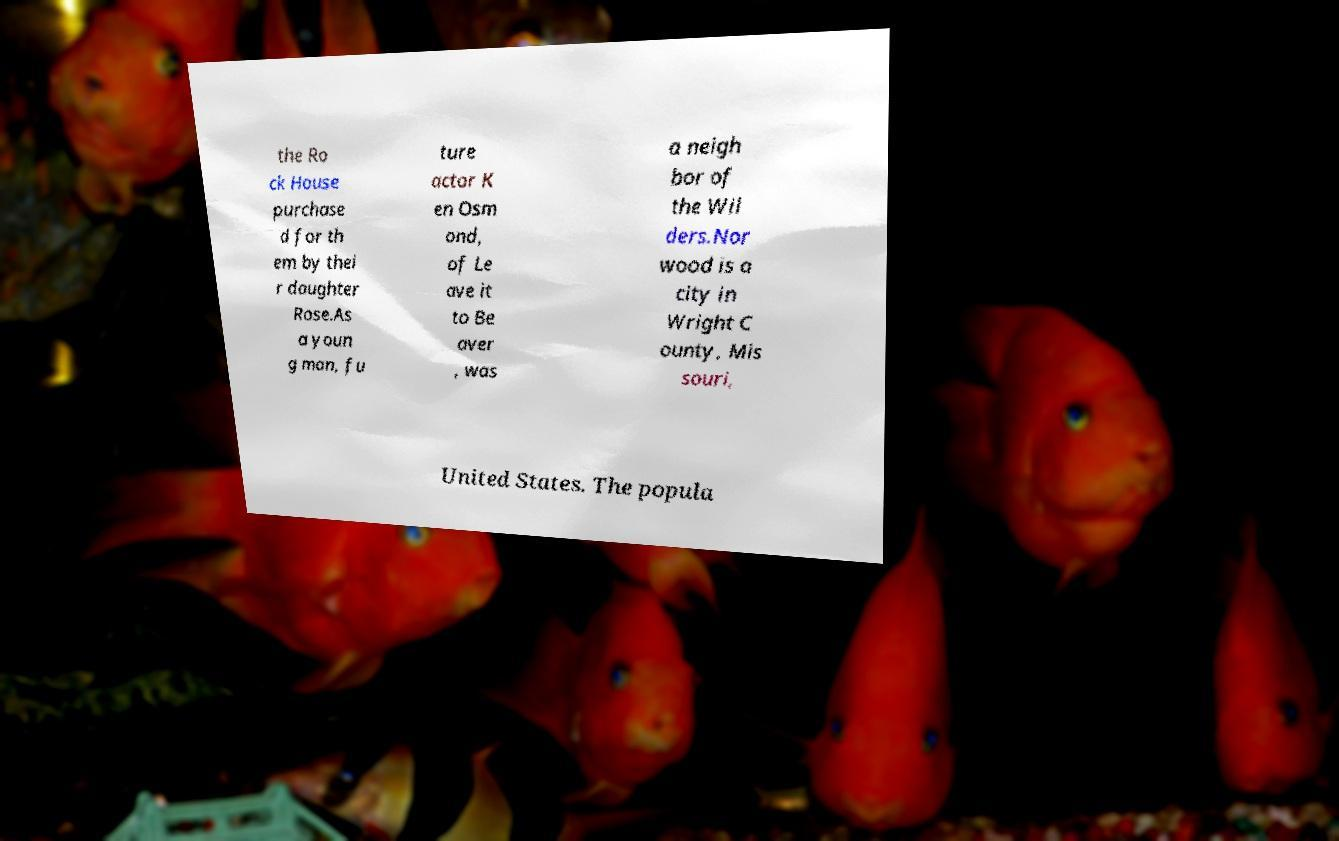Could you assist in decoding the text presented in this image and type it out clearly? the Ro ck House purchase d for th em by thei r daughter Rose.As a youn g man, fu ture actor K en Osm ond, of Le ave it to Be aver , was a neigh bor of the Wil ders.Nor wood is a city in Wright C ounty, Mis souri, United States. The popula 